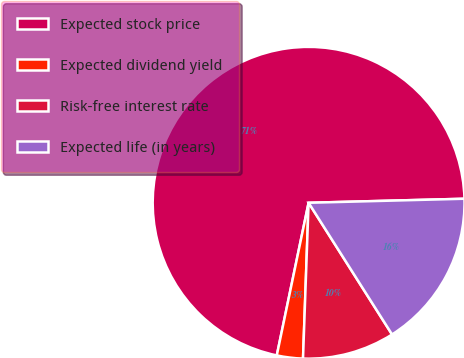Convert chart. <chart><loc_0><loc_0><loc_500><loc_500><pie_chart><fcel>Expected stock price<fcel>Expected dividend yield<fcel>Risk-free interest rate<fcel>Expected life (in years)<nl><fcel>71.31%<fcel>2.7%<fcel>9.56%<fcel>16.42%<nl></chart> 